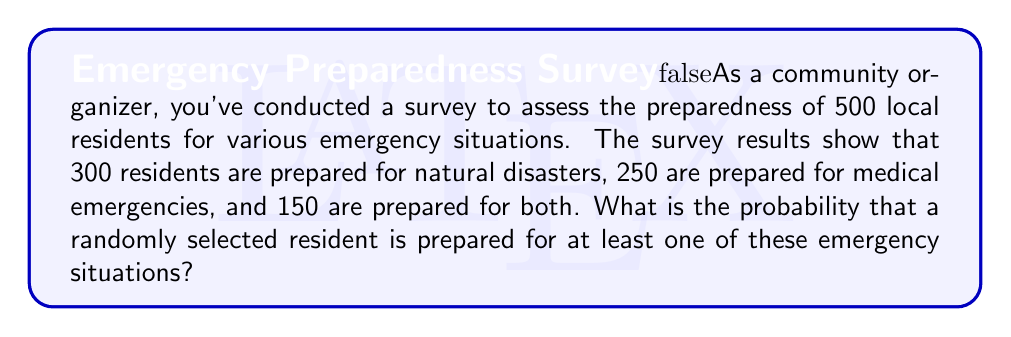Solve this math problem. Let's approach this step-by-step using set theory and probability:

1) Let's define our sets:
   A = residents prepared for natural disasters
   B = residents prepared for medical emergencies

2) We're given:
   n(A) = 300 (number of residents in set A)
   n(B) = 250 (number of residents in set B)
   n(A ∩ B) = 150 (number of residents in both A and B)
   Total residents = 500

3) We need to find P(A ∪ B), the probability of a resident being in A or B or both.

4) We can use the formula:
   n(A ∪ B) = n(A) + n(B) - n(A ∩ B)

5) Plugging in our values:
   n(A ∪ B) = 300 + 250 - 150 = 400

6) Now, to find the probability, we divide by the total number of residents:

   P(A ∪ B) = n(A ∪ B) / Total residents
            = 400 / 500
            = 4/5
            = 0.8

Therefore, the probability that a randomly selected resident is prepared for at least one of these emergency situations is 0.8 or 80%.
Answer: 0.8 